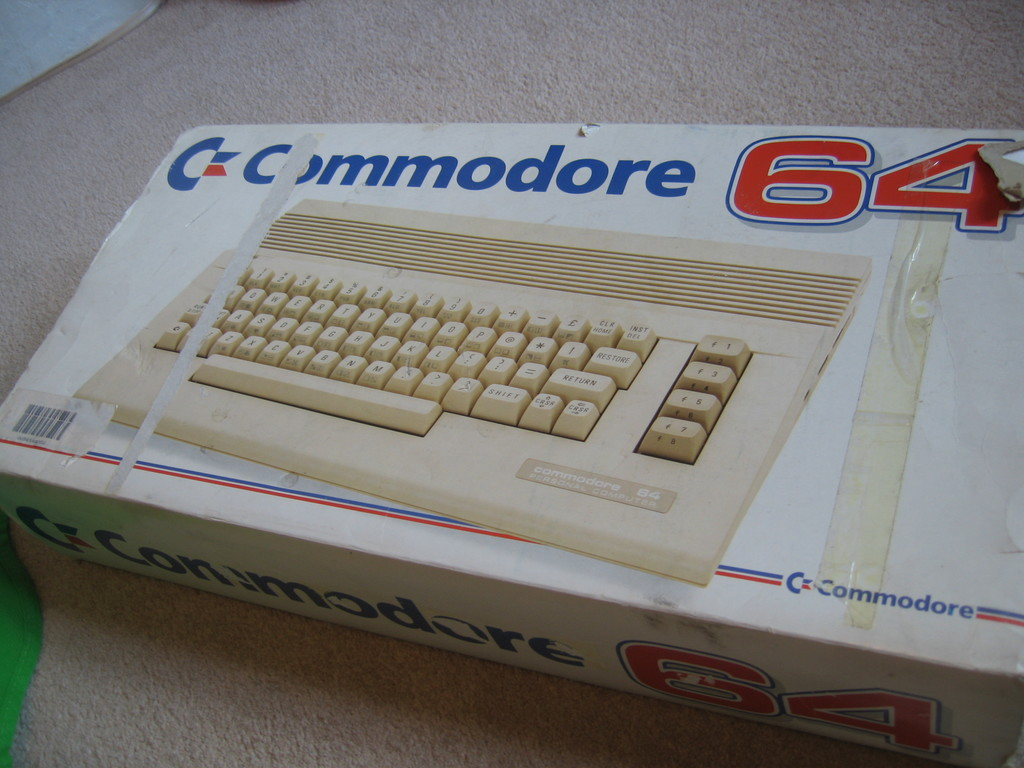Pretend you're creating an advertisement for the Commodore 64 in the 1980s. What would it say? Step into the future of home computing with the Commodore 64! Unleash your creativity with cutting-edge color graphics and sound. From thrilling games to managing your household finances, the C64 makes it all possible at an unbeatable price. Don't just dream about tomorrow—own it today for just $595! 